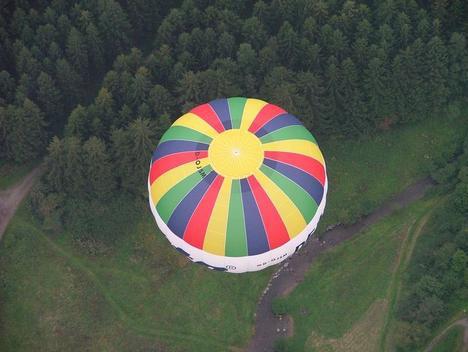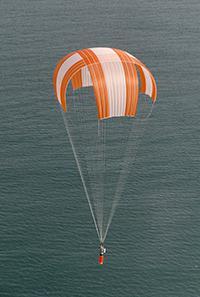The first image is the image on the left, the second image is the image on the right. Examine the images to the left and right. Is the description "One image shows a single balloon in midair with people in its basket and a view of the landscape under it including green areas." accurate? Answer yes or no. No. The first image is the image on the left, the second image is the image on the right. Examine the images to the left and right. Is the description "An image shows the interior of a balloon which is lying on the ground." accurate? Answer yes or no. No. 